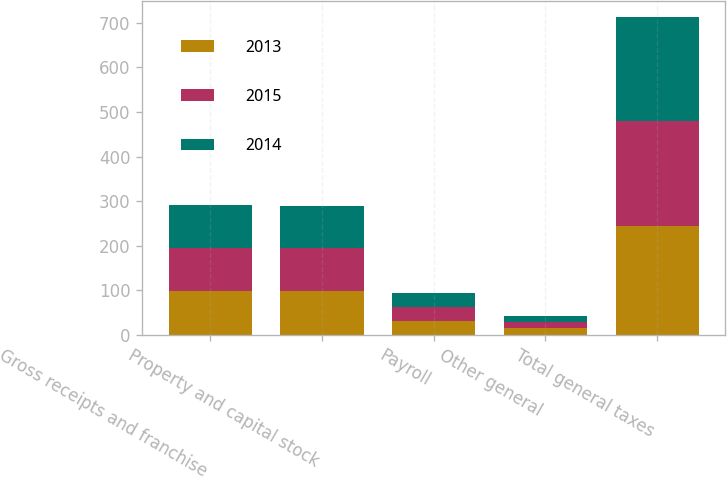Convert chart to OTSL. <chart><loc_0><loc_0><loc_500><loc_500><stacked_bar_chart><ecel><fcel>Gross receipts and franchise<fcel>Property and capital stock<fcel>Payroll<fcel>Other general<fcel>Total general taxes<nl><fcel>2013<fcel>99<fcel>98<fcel>31<fcel>15<fcel>243<nl><fcel>2015<fcel>96<fcel>96<fcel>31<fcel>13<fcel>236<nl><fcel>2014<fcel>96<fcel>94<fcel>31<fcel>13<fcel>234<nl></chart> 